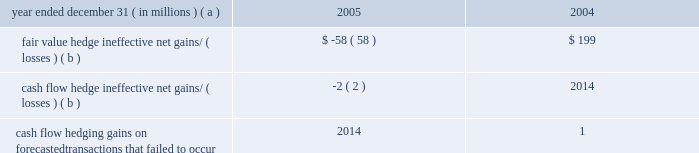Jpmorgan chase & co .
/ 2005 annual report 123 litigation reserve the firm maintains litigation reserves for certain of its litigations , including its material legal proceedings .
While the outcome of litigation is inherently uncertain , management believes , in light of all information known to it at december 31 , 2005 , that the firm 2019s litigation reserves were adequate at such date .
Management reviews litigation reserves periodically , and the reserves may be increased or decreased in the future to reflect further litigation devel- opments .
The firm believes it has meritorious defenses to claims asserted against it in its currently outstanding litigation and , with respect to such liti- gation , intends to continue to defend itself vigorously , litigating or settling cases according to management 2019s judgment as to what is in the best interest of stockholders .
Note 26 2013 accounting for derivative instruments and hedging activities derivative instruments enable end users to increase , reduce or alter exposure to credit or market risks .
The value of a derivative is derived from its reference to an underlying variable or combination of variables such as equity , foreign exchange , credit , commodity or interest rate prices or indices .
Jpmorgan chase makes markets in derivatives for customers and also is an end-user of derivatives in order to manage the firm 2019s exposure to credit and market risks .
Sfas 133 , as amended by sfas 138 and sfas 149 , establishes accounting and reporting standards for derivative instruments , including those used for trading and hedging activities , and derivative instruments embedded in other contracts .
All free-standing derivatives , whether designated for hedging rela- tionships or not , are required to be recorded on the balance sheet at fair value .
The accounting for changes in value of a derivative depends on whether the contract is for trading purposes or has been designated and qualifies for hedge accounting .
The majority of the firm 2019s derivatives are entered into for trading purposes .
The firm also uses derivatives as an end user to hedge market exposures , modify the interest rate characteristics of related balance sheet instruments or meet longer-term investment objectives .
Both trading and end-user derivatives are recorded at fair value in trading assets and trading liabilities as set forth in note 3 on page 94 of this annual report .
In order to qualify for hedge accounting , a derivative must be considered highly effective at reducing the risk associated with the exposure being hedged .
Each derivative must be designated as a hedge , with documentation of the risk management objective and strategy , including identification of the hedging instrument , the hedged item and the risk exposure , and how effectiveness is to be assessed prospectively and retrospectively .
The extent to which a hedging instrument is effective at achieving offsetting changes in fair value or cash flows must be assessed at least quarterly .
Any ineffectiveness must be reported in current-period earnings .
For qualifying fair value hedges , all changes in the fair value of the derivative and in the fair value of the item for the risk being hedged are recognized in earnings .
If the hedge relationship is terminated , then the fair value adjust- ment to the hedged item continues to be reported as part of the basis of the item and is amortized to earnings as a yield adjustment .
For qualifying cash flow hedges , the effective portion of the change in the fair value of the derivative is recorded in other comprehensive income and recognized in the income statement when the hedged cash flows affect earnings .
The ineffective portions of cash flow hedges are immediately recognized in earnings .
If the hedge relationship is terminated , then the change in fair value of the derivative recorded in other comprehensive income is recognized when the cash flows that were hedged occur , consistent with the original hedge strategy .
For hedge relationships discontinued because the forecasted transaction is not expected to occur according to the original strategy , any related derivative amounts recorded in other comprehensive income are immediately recognized in earnings .
For qualifying net investment hedges , changes in the fair value of the derivative or the revaluation of the foreign currency 2013denominated debt instrument are recorded in the translation adjustments account within other comprehensive income .
Any ineffective portions of net investment hedges are immediately recognized in earnings .
Jpmorgan chase 2019s fair value hedges primarily include hedges of fixed-rate long-term debt , loans , afs securities and msrs .
Interest rate swaps are the most common type of derivative contract used to modify exposure to interest rate risk , converting fixed-rate assets and liabilities to a floating rate .
Interest rate options , swaptions and forwards are also used in combination with interest rate swaps to hedge the fair value of the firm 2019s msrs .
For a further discussion of msr risk management activities , see note 15 on pages 114 2013116 of this annual report .
All amounts have been included in earnings consistent with the classification of the hedged item , primarily net interest income , mortgage fees and related income , and other income .
The firm did not recognize any gains or losses during 2005 on firm commitments that no longer qualify as fair value hedges .
Jpmorgan chase also enters into derivative contracts to hedge exposure to variability in cash flows from floating-rate financial instruments and forecasted transactions , primarily the rollover of short-term assets and liabilities , and foreign currency-denominated revenues and expenses .
Interest rate swaps , futures and forward contracts are the most common instruments used to reduce the impact of interest rate and foreign exchange rate changes on future earnings .
All amounts affecting earnings have been recognized consistent with the classification of the hedged item , primarily net interest income .
The firm uses forward foreign exchange contracts and foreign currency- denominated debt instruments to protect the value of net investments in foreign currencies in non-u.s .
Subsidiaries .
The portion of the hedging instru- ments excluded from the assessment of hedge effectiveness ( forward points ) is recorded in net interest income .
The table presents derivative instrument hedging-related activities for the periods indicated : year ended december 31 , ( in millions ) ( a ) 2005 2004 fair value hedge ineffective net gains/ ( losses ) ( b ) $ ( 58 ) $ 199 cash flow hedge ineffective net gains/ ( losses ) ( b ) ( 2 ) 2014 cash flow hedging gains on forecasted transactions that failed to occur 2014 1 ( a ) 2004 results include six months of the combined firm 2019s results and six months of heritage jpmorgan chase results .
( b ) includes ineffectiveness and the components of hedging instruments that have been excluded from the assessment of hedge effectiveness .
Over the next 12 months , it is expected that $ 44 million ( after-tax ) of net gains recorded in other comprehensive income at december 31 , 2005 , will be recognized in earnings .
The maximum length of time over which forecasted transactions are hedged is 10 years , and such transactions primarily relate to core lending and borrowing activities .
Jpmorgan chase does not seek to apply hedge accounting to all of the firm 2019s economic hedges .
For example , the firm does not apply hedge accounting to standard credit derivatives used to manage the credit risk of loans and commitments because of the difficulties in qualifying such contracts as hedges under sfas 133 .
Similarly , the firm does not apply hedge accounting to certain interest rate derivatives used as economic hedges. .
Jpmorgan chase & co .
/ 2005 annual report 123 litigation reserve the firm maintains litigation reserves for certain of its litigations , including its material legal proceedings .
While the outcome of litigation is inherently uncertain , management believes , in light of all information known to it at december 31 , 2005 , that the firm 2019s litigation reserves were adequate at such date .
Management reviews litigation reserves periodically , and the reserves may be increased or decreased in the future to reflect further litigation devel- opments .
The firm believes it has meritorious defenses to claims asserted against it in its currently outstanding litigation and , with respect to such liti- gation , intends to continue to defend itself vigorously , litigating or settling cases according to management 2019s judgment as to what is in the best interest of stockholders .
Note 26 2013 accounting for derivative instruments and hedging activities derivative instruments enable end users to increase , reduce or alter exposure to credit or market risks .
The value of a derivative is derived from its reference to an underlying variable or combination of variables such as equity , foreign exchange , credit , commodity or interest rate prices or indices .
Jpmorgan chase makes markets in derivatives for customers and also is an end-user of derivatives in order to manage the firm 2019s exposure to credit and market risks .
Sfas 133 , as amended by sfas 138 and sfas 149 , establishes accounting and reporting standards for derivative instruments , including those used for trading and hedging activities , and derivative instruments embedded in other contracts .
All free-standing derivatives , whether designated for hedging rela- tionships or not , are required to be recorded on the balance sheet at fair value .
The accounting for changes in value of a derivative depends on whether the contract is for trading purposes or has been designated and qualifies for hedge accounting .
The majority of the firm 2019s derivatives are entered into for trading purposes .
The firm also uses derivatives as an end user to hedge market exposures , modify the interest rate characteristics of related balance sheet instruments or meet longer-term investment objectives .
Both trading and end-user derivatives are recorded at fair value in trading assets and trading liabilities as set forth in note 3 on page 94 of this annual report .
In order to qualify for hedge accounting , a derivative must be considered highly effective at reducing the risk associated with the exposure being hedged .
Each derivative must be designated as a hedge , with documentation of the risk management objective and strategy , including identification of the hedging instrument , the hedged item and the risk exposure , and how effectiveness is to be assessed prospectively and retrospectively .
The extent to which a hedging instrument is effective at achieving offsetting changes in fair value or cash flows must be assessed at least quarterly .
Any ineffectiveness must be reported in current-period earnings .
For qualifying fair value hedges , all changes in the fair value of the derivative and in the fair value of the item for the risk being hedged are recognized in earnings .
If the hedge relationship is terminated , then the fair value adjust- ment to the hedged item continues to be reported as part of the basis of the item and is amortized to earnings as a yield adjustment .
For qualifying cash flow hedges , the effective portion of the change in the fair value of the derivative is recorded in other comprehensive income and recognized in the income statement when the hedged cash flows affect earnings .
The ineffective portions of cash flow hedges are immediately recognized in earnings .
If the hedge relationship is terminated , then the change in fair value of the derivative recorded in other comprehensive income is recognized when the cash flows that were hedged occur , consistent with the original hedge strategy .
For hedge relationships discontinued because the forecasted transaction is not expected to occur according to the original strategy , any related derivative amounts recorded in other comprehensive income are immediately recognized in earnings .
For qualifying net investment hedges , changes in the fair value of the derivative or the revaluation of the foreign currency 2013denominated debt instrument are recorded in the translation adjustments account within other comprehensive income .
Any ineffective portions of net investment hedges are immediately recognized in earnings .
Jpmorgan chase 2019s fair value hedges primarily include hedges of fixed-rate long-term debt , loans , afs securities and msrs .
Interest rate swaps are the most common type of derivative contract used to modify exposure to interest rate risk , converting fixed-rate assets and liabilities to a floating rate .
Interest rate options , swaptions and forwards are also used in combination with interest rate swaps to hedge the fair value of the firm 2019s msrs .
For a further discussion of msr risk management activities , see note 15 on pages 114 2013116 of this annual report .
All amounts have been included in earnings consistent with the classification of the hedged item , primarily net interest income , mortgage fees and related income , and other income .
The firm did not recognize any gains or losses during 2005 on firm commitments that no longer qualify as fair value hedges .
Jpmorgan chase also enters into derivative contracts to hedge exposure to variability in cash flows from floating-rate financial instruments and forecasted transactions , primarily the rollover of short-term assets and liabilities , and foreign currency-denominated revenues and expenses .
Interest rate swaps , futures and forward contracts are the most common instruments used to reduce the impact of interest rate and foreign exchange rate changes on future earnings .
All amounts affecting earnings have been recognized consistent with the classification of the hedged item , primarily net interest income .
The firm uses forward foreign exchange contracts and foreign currency- denominated debt instruments to protect the value of net investments in foreign currencies in non-u.s .
Subsidiaries .
The portion of the hedging instru- ments excluded from the assessment of hedge effectiveness ( forward points ) is recorded in net interest income .
The following table presents derivative instrument hedging-related activities for the periods indicated : year ended december 31 , ( in millions ) ( a ) 2005 2004 fair value hedge ineffective net gains/ ( losses ) ( b ) $ ( 58 ) $ 199 cash flow hedge ineffective net gains/ ( losses ) ( b ) ( 2 ) 2014 cash flow hedging gains on forecasted transactions that failed to occur 2014 1 ( a ) 2004 results include six months of the combined firm 2019s results and six months of heritage jpmorgan chase results .
( b ) includes ineffectiveness and the components of hedging instruments that have been excluded from the assessment of hedge effectiveness .
Over the next 12 months , it is expected that $ 44 million ( after-tax ) of net gains recorded in other comprehensive income at december 31 , 2005 , will be recognized in earnings .
The maximum length of time over which forecasted transactions are hedged is 10 years , and such transactions primarily relate to core lending and borrowing activities .
Jpmorgan chase does not seek to apply hedge accounting to all of the firm 2019s economic hedges .
For example , the firm does not apply hedge accounting to standard credit derivatives used to manage the credit risk of loans and commitments because of the difficulties in qualifying such contracts as hedges under sfas 133 .
Similarly , the firm does not apply hedge accounting to certain interest rate derivatives used as economic hedges. .
What were the total 2005 and 2004 fair value hedge gains/ ( losses ) due to ineffectiveness , in us$ m? 
Computations: (-58 + 199)
Answer: 141.0. 